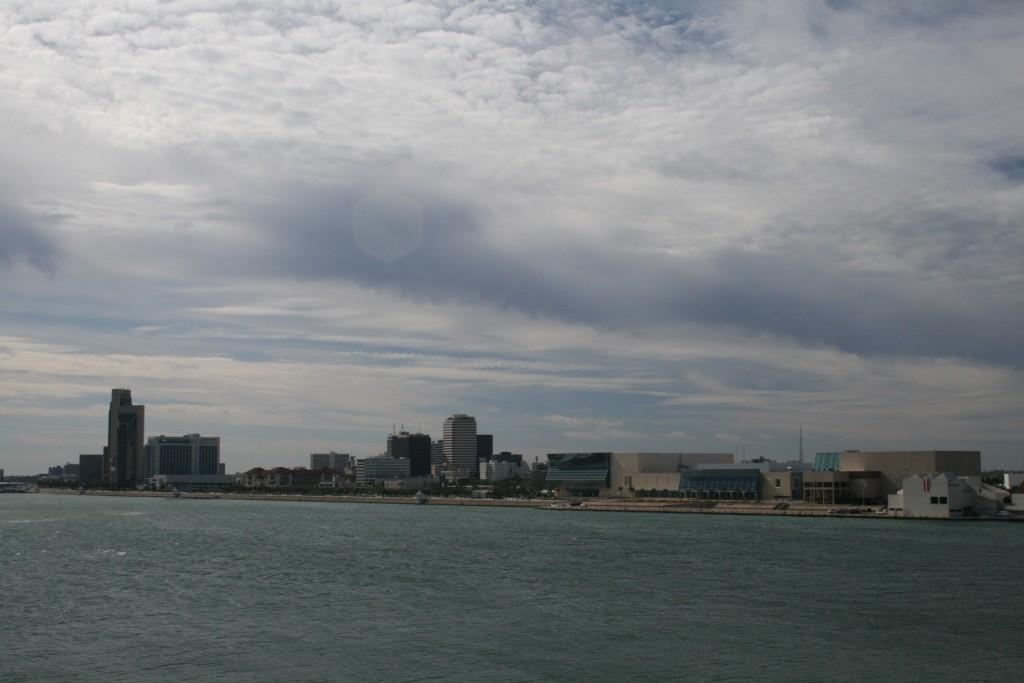What is visible at the bottom of the image? There is water visible at the bottom of the image. What can be seen in the background of the image? Buildings, trees, poles, windows, and clouds are visible in the background of the image. What type of trousers is the judge wearing in the park in the image? There is no judge or park present in the image, and therefore no trousers can be observed. 